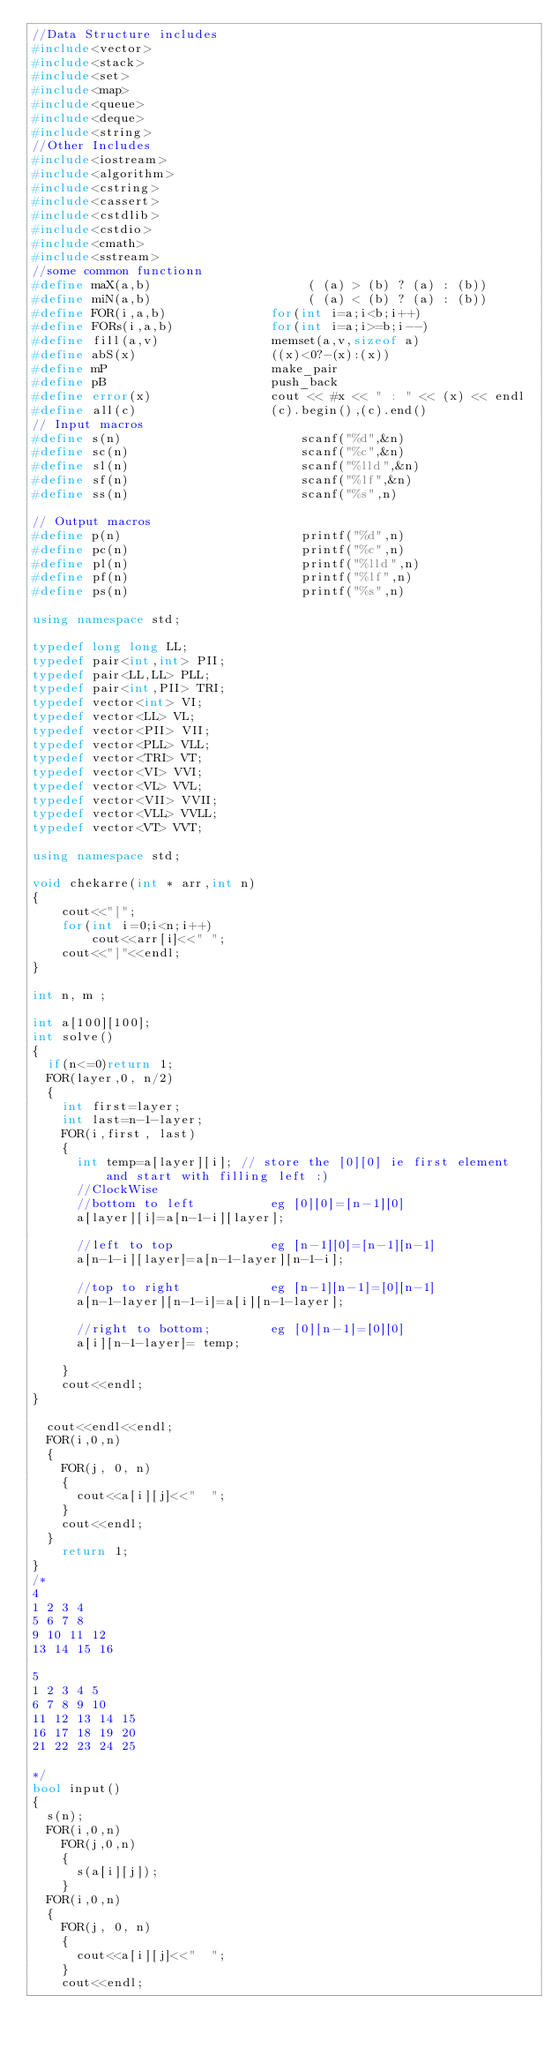<code> <loc_0><loc_0><loc_500><loc_500><_C++_>//Data Structure includes
#include<vector>
#include<stack>
#include<set>
#include<map>
#include<queue>
#include<deque>
#include<string>
//Other Includes
#include<iostream>
#include<algorithm>
#include<cstring>
#include<cassert>
#include<cstdlib>
#include<cstdio>
#include<cmath>
#include<sstream>
//some common functionn
#define maX(a,b)                     ( (a) > (b) ? (a) : (b))
#define miN(a,b)                     ( (a) < (b) ? (a) : (b))
#define FOR(i,a,b)              for(int i=a;i<b;i++)
#define FORs(i,a,b)             for(int i=a;i>=b;i--)
#define fill(a,v)               memset(a,v,sizeof a)
#define abS(x)                  ((x)<0?-(x):(x))
#define mP                      make_pair
#define pB                      push_back
#define error(x)                cout << #x << " : " << (x) << endl
#define all(c)                  (c).begin(),(c).end()
// Input macros
#define s(n)                        scanf("%d",&n)
#define sc(n)                       scanf("%c",&n)
#define sl(n)                       scanf("%lld",&n)
#define sf(n)                       scanf("%lf",&n)
#define ss(n)                       scanf("%s",n)

// Output macros
#define p(n)                        printf("%d",n)
#define pc(n)                       printf("%c",n)
#define pl(n)                       printf("%lld",n)
#define pf(n)                       printf("%lf",n)
#define ps(n)                       printf("%s",n)

using namespace std;

typedef long long LL;
typedef pair<int,int> PII;
typedef pair<LL,LL> PLL;
typedef pair<int,PII> TRI;
typedef vector<int> VI;
typedef vector<LL> VL;
typedef vector<PII> VII;
typedef vector<PLL> VLL;
typedef vector<TRI> VT;
typedef vector<VI> VVI;
typedef vector<VL> VVL;
typedef vector<VII> VVII;
typedef vector<VLL> VVLL;
typedef vector<VT> VVT;

using namespace std;

void chekarre(int * arr,int n)
{
    cout<<"[";
    for(int i=0;i<n;i++)
        cout<<arr[i]<<" ";
    cout<<"]"<<endl;
}

int n, m ;

int a[100][100];
int solve()
{
	if(n<=0)return 1;
	FOR(layer,0, n/2)
	{
		int first=layer;
		int last=n-1-layer;
		FOR(i,first, last)
		{
			int temp=a[layer][i]; // store the [0][0] ie first element and start with filling left :)
			//ClockWise
			//bottom to left         	eg [0][0]=[n-1][0]
			a[layer][i]=a[n-1-i][layer];

			//left to top							eg [n-1][0]=[n-1][n-1]
			a[n-1-i][layer]=a[n-1-layer][n-1-i];

			//top to right						eg [n-1][n-1]=[0][n-1]
			a[n-1-layer][n-1-i]=a[i][n-1-layer];

			//right to bottom;				eg [0][n-1]=[0][0]
			a[i][n-1-layer]= temp;

		}
		cout<<endl;
}

	cout<<endl<<endl;
	FOR(i,0,n)
	{
		FOR(j, 0, n)
		{
			cout<<a[i][j]<<"  ";
		}
		cout<<endl;
	}
    return 1;
}
/*
4
1 2 3 4
5 6 7 8
9 10 11 12
13 14 15 16

5
1 2 3 4 5
6 7 8 9 10
11 12 13 14 15
16 17 18 19 20
21 22 23 24 25

*/
bool input()
{
	s(n);
	FOR(i,0,n)
		FOR(j,0,n)
		{
			s(a[i][j]);
		}
	FOR(i,0,n)
	{
		FOR(j, 0, n)
		{
			cout<<a[i][j]<<"  ";
		}
		cout<<endl;</code> 